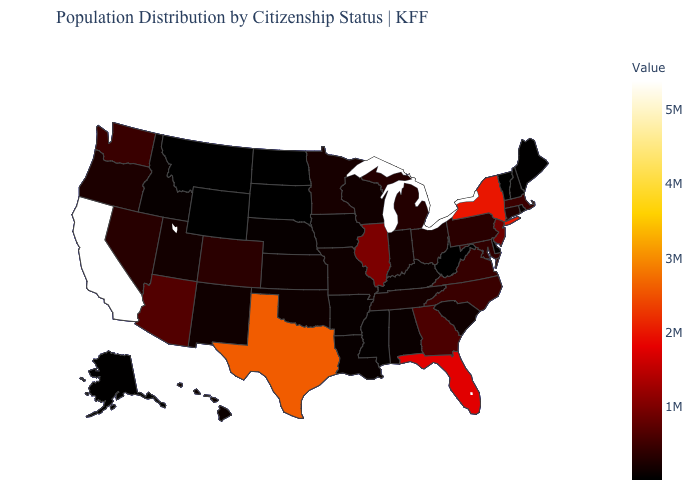Does California have the highest value in the USA?
Write a very short answer. Yes. Does California have the highest value in the USA?
Write a very short answer. Yes. 